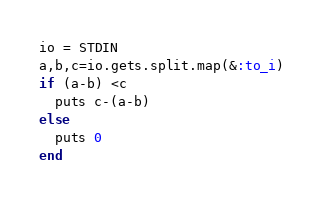Convert code to text. <code><loc_0><loc_0><loc_500><loc_500><_Ruby_>io = STDIN
a,b,c=io.gets.split.map(&:to_i)
if (a-b) <c
  puts c-(a-b)
else
  puts 0
end
</code> 